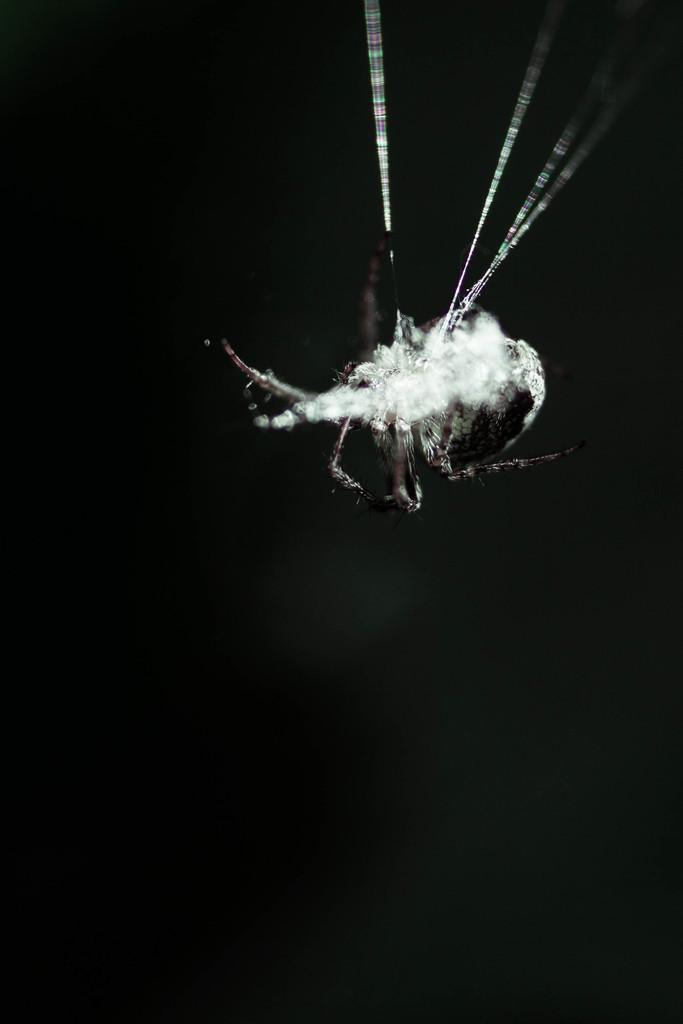What type of living organism can be seen in the image? There is an insect in the image. What is the color of the background in the image? The background of the image is black. What type of rod can be seen in the image? There is no rod present in the image. Is there a bedroom visible in the image? There is no bedroom present in the image. What type of team is featured in the image? There is no team present in the image. 